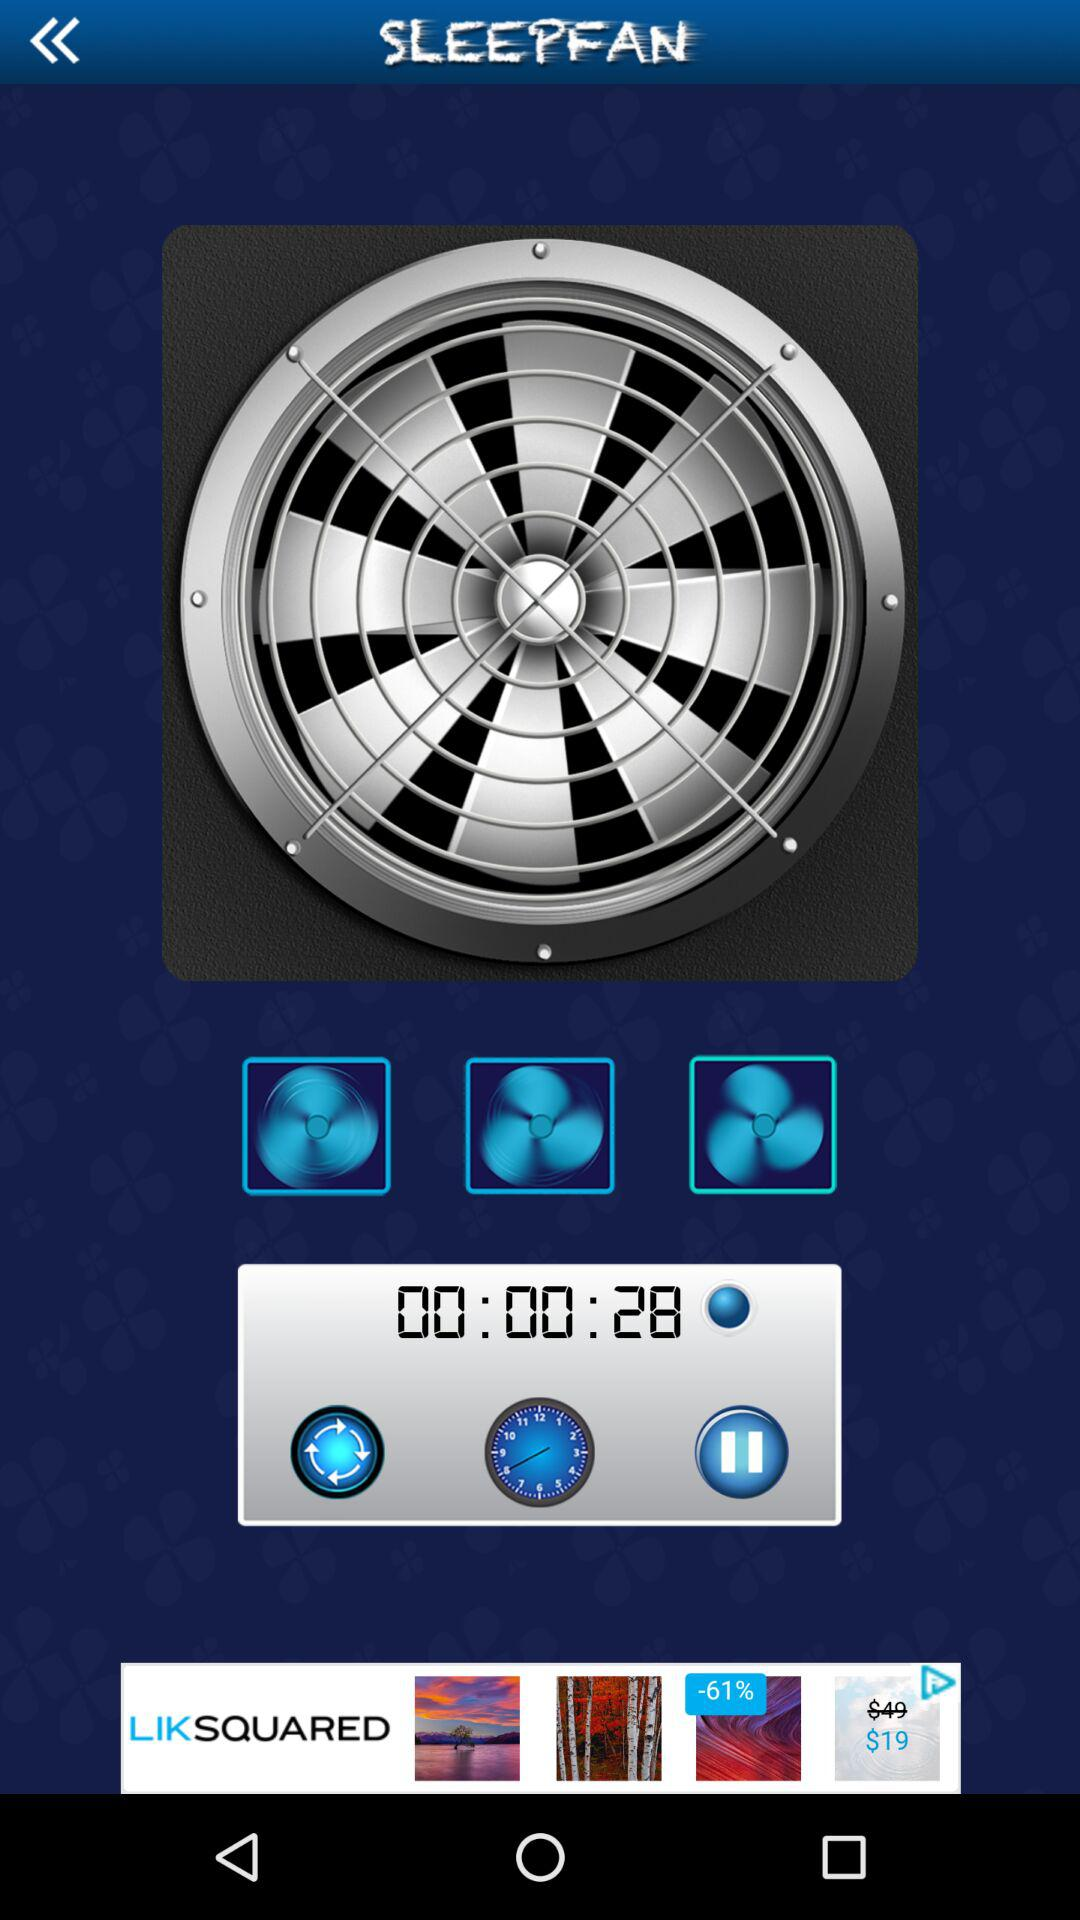How many seconds has the fan been running for?
Answer the question using a single word or phrase. 28 